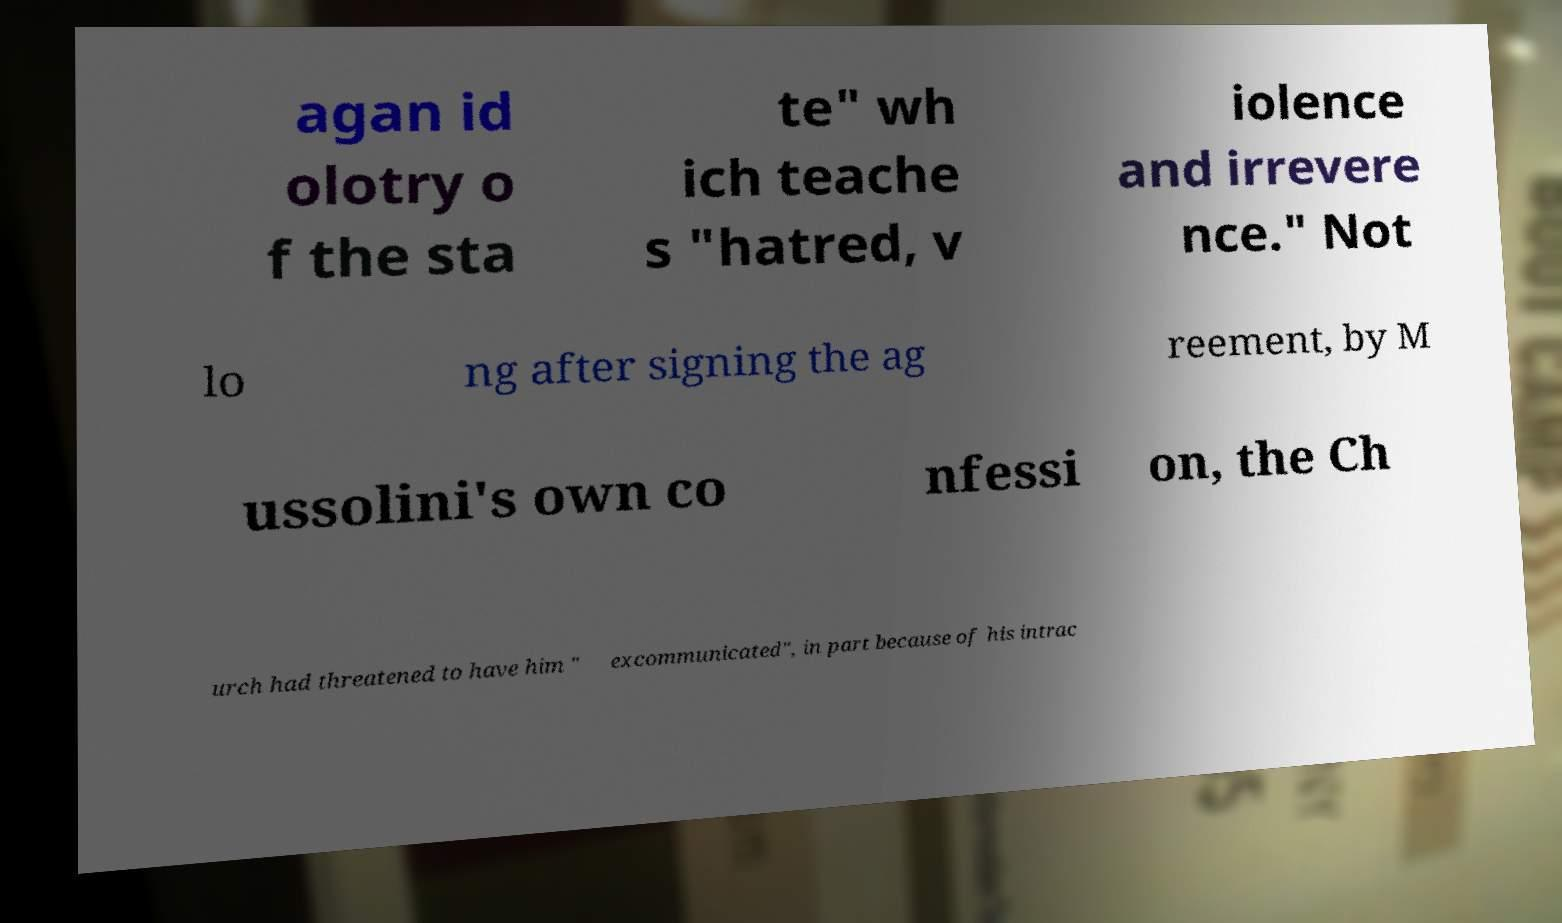Can you accurately transcribe the text from the provided image for me? agan id olotry o f the sta te" wh ich teache s "hatred, v iolence and irrevere nce." Not lo ng after signing the ag reement, by M ussolini's own co nfessi on, the Ch urch had threatened to have him " excommunicated", in part because of his intrac 